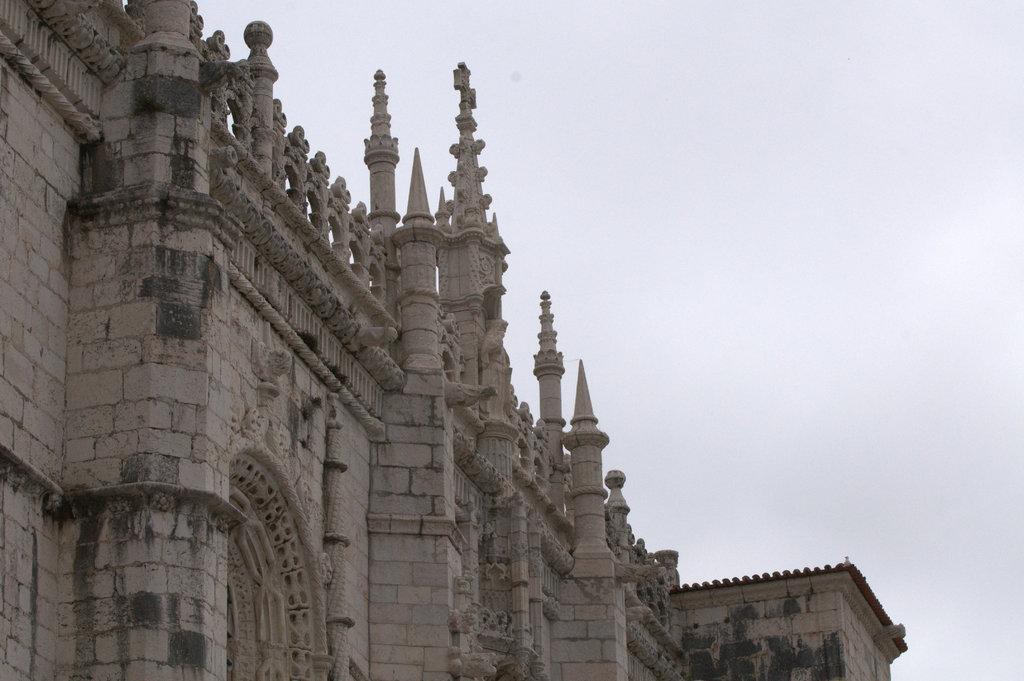In one or two sentences, can you explain what this image depicts? In this picture I can see a building. In the background I can see the sky. 